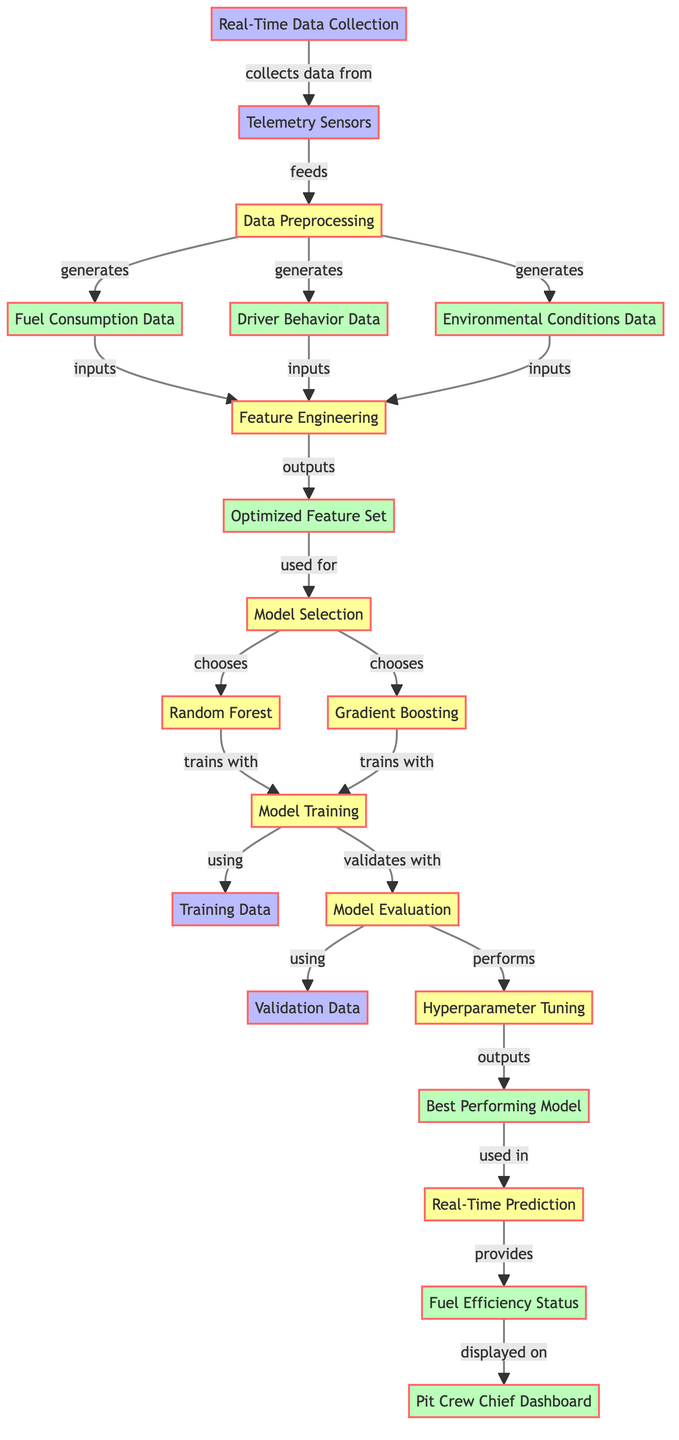What's the first step in the diagram? The diagram starts with "Real-Time Data Collection", which is the first node, representing the initial action of gathering data.
Answer: Real-Time Data Collection How many output nodes are there? By counting the nodes labeled as outputs, we find there are four output nodes: "Fuel Consumption Data", "Driver Behavior Data", "Environmental Conditions Data", and "Fuel Efficiency Status".
Answer: Four What are the two methods used for Model Selection? The diagram shows that "Random Forest" and "Gradient Boosting" are the two methods selected for modeling, indicating the choice of algorithms that could be applied.
Answer: Random Forest, Gradient Boosting Which process immediately follows Feature Engineering? After "Feature Engineering", which is the seventh node, the next step is "Model Selection", indicating what comes next in the sequence of optimization processes.
Answer: Model Selection What data is used for Model Training? The "Training Data" node is specifically indicated as the input used for the "Model Training" process, highlighting the required data to develop the model.
Answer: Training Data Which output is displayed on the Pit Crew Chief Dashboard? The "Fuel Efficiency Status" node is directly labeled as providing information that is displayed on the "Pit Crew Chief Dashboard", making this relationship clear.
Answer: Fuel Efficiency Status Which process utilizes both Training Data and Validation Data? The "Model Evaluation" process uses both "Training Data" and "Validation Data" as input, showing that both datasets are necessary for assessing the model's performance.
Answer: Model Evaluation What is the relationship between Hyperparameter Tuning and Best Performing Model? After "Hyperparameter Tuning", the output is labeled as "Best Performing Model", indicating that tuning the model's parameters leads to identifying the most effective model for predictions.
Answer: Best Performing Model In which stage do Environmental Conditions Data get generated? "Environmental Conditions Data" is generated during the "Data Preprocessing" stage, which takes the input from telemetry sensors and processes it accordingly.
Answer: Data Preprocessing 